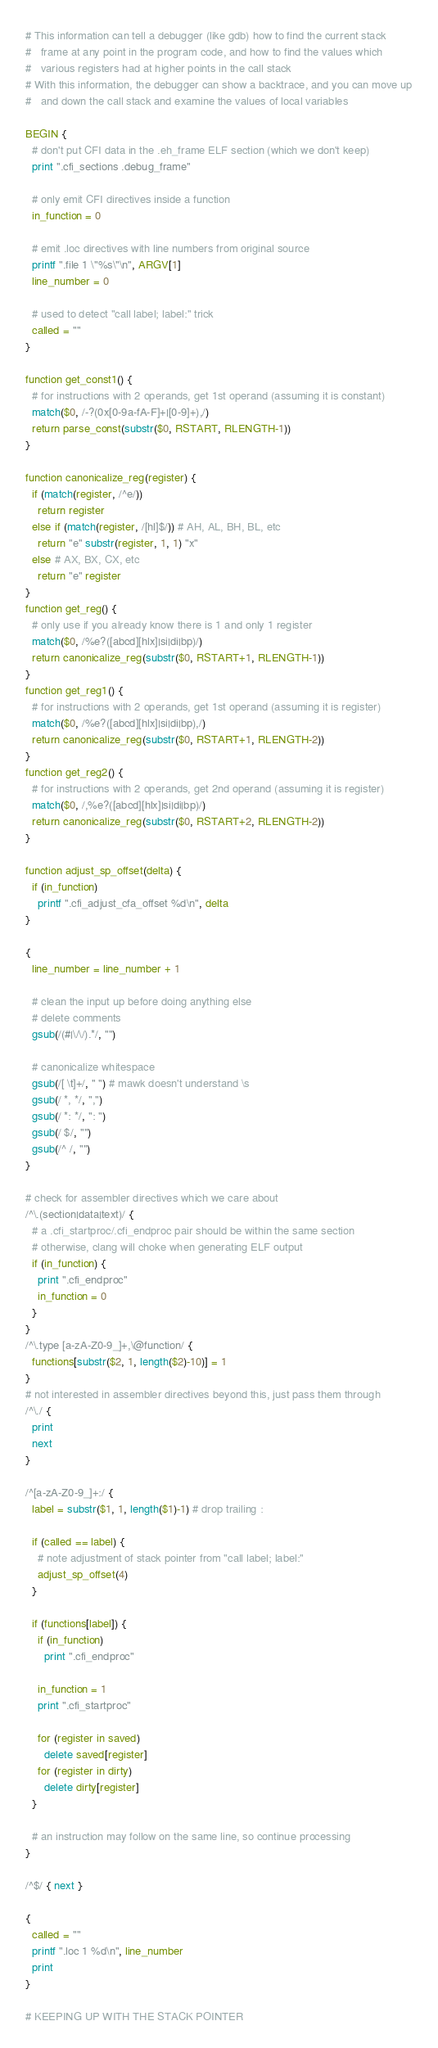<code> <loc_0><loc_0><loc_500><loc_500><_Awk_># This information can tell a debugger (like gdb) how to find the current stack
#   frame at any point in the program code, and how to find the values which
#   various registers had at higher points in the call stack
# With this information, the debugger can show a backtrace, and you can move up
#   and down the call stack and examine the values of local variables

BEGIN {
  # don't put CFI data in the .eh_frame ELF section (which we don't keep)
  print ".cfi_sections .debug_frame"

  # only emit CFI directives inside a function
  in_function = 0

  # emit .loc directives with line numbers from original source
  printf ".file 1 \"%s\"\n", ARGV[1]
  line_number = 0

  # used to detect "call label; label:" trick
  called = ""
}

function get_const1() {
  # for instructions with 2 operands, get 1st operand (assuming it is constant)
  match($0, /-?(0x[0-9a-fA-F]+|[0-9]+),/)
  return parse_const(substr($0, RSTART, RLENGTH-1))
}

function canonicalize_reg(register) {
  if (match(register, /^e/))
    return register
  else if (match(register, /[hl]$/)) # AH, AL, BH, BL, etc
    return "e" substr(register, 1, 1) "x"
  else # AX, BX, CX, etc
    return "e" register
}
function get_reg() {
  # only use if you already know there is 1 and only 1 register
  match($0, /%e?([abcd][hlx]|si|di|bp)/)
  return canonicalize_reg(substr($0, RSTART+1, RLENGTH-1))
}
function get_reg1() {
  # for instructions with 2 operands, get 1st operand (assuming it is register)
  match($0, /%e?([abcd][hlx]|si|di|bp),/)
  return canonicalize_reg(substr($0, RSTART+1, RLENGTH-2))
}
function get_reg2() {
  # for instructions with 2 operands, get 2nd operand (assuming it is register)
  match($0, /,%e?([abcd][hlx]|si|di|bp)/)
  return canonicalize_reg(substr($0, RSTART+2, RLENGTH-2))
}

function adjust_sp_offset(delta) {
  if (in_function)
    printf ".cfi_adjust_cfa_offset %d\n", delta
}

{
  line_number = line_number + 1

  # clean the input up before doing anything else
  # delete comments
  gsub(/(#|\/\/).*/, "")

  # canonicalize whitespace
  gsub(/[ \t]+/, " ") # mawk doesn't understand \s
  gsub(/ *, */, ",")
  gsub(/ *: */, ": ")
  gsub(/ $/, "")
  gsub(/^ /, "")
}

# check for assembler directives which we care about
/^\.(section|data|text)/ {
  # a .cfi_startproc/.cfi_endproc pair should be within the same section
  # otherwise, clang will choke when generating ELF output
  if (in_function) {
    print ".cfi_endproc"
    in_function = 0
  }
}
/^\.type [a-zA-Z0-9_]+,\@function/ {
  functions[substr($2, 1, length($2)-10)] = 1
}
# not interested in assembler directives beyond this, just pass them through
/^\./ {
  print
  next
}

/^[a-zA-Z0-9_]+:/ {
  label = substr($1, 1, length($1)-1) # drop trailing :

  if (called == label) {
    # note adjustment of stack pointer from "call label; label:"
    adjust_sp_offset(4)
  }

  if (functions[label]) {
    if (in_function)
      print ".cfi_endproc"

    in_function = 1
    print ".cfi_startproc"

    for (register in saved)
      delete saved[register]
    for (register in dirty)
      delete dirty[register]
  }

  # an instruction may follow on the same line, so continue processing
}

/^$/ { next }

{
  called = ""
  printf ".loc 1 %d\n", line_number
  print
}

# KEEPING UP WITH THE STACK POINTER</code> 